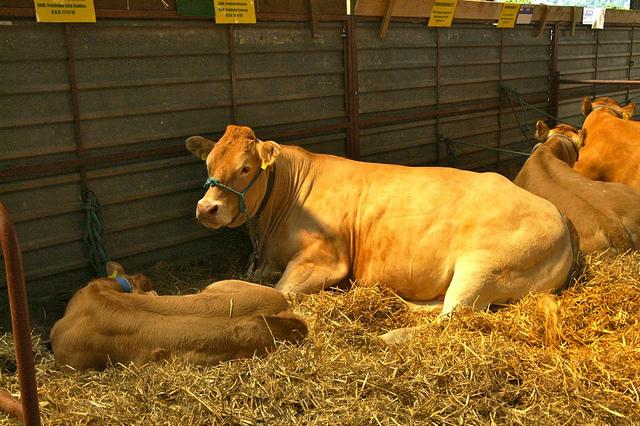What color is the handle tied around the sunlit cow's face? Please explain your reasoning. green. The handle is not blue, red, or yellow. 